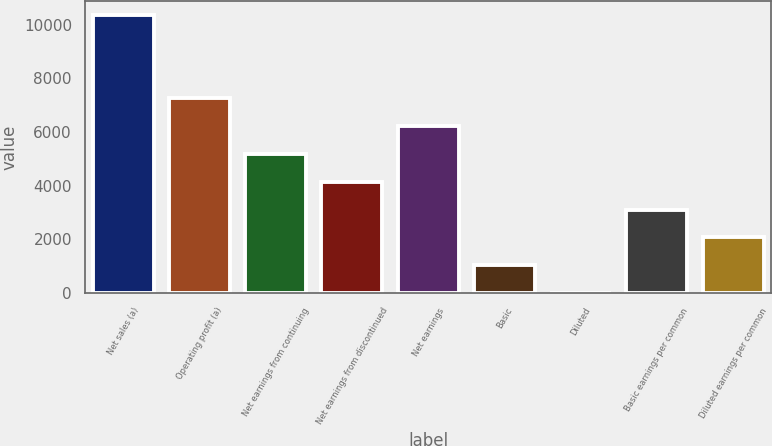Convert chart to OTSL. <chart><loc_0><loc_0><loc_500><loc_500><bar_chart><fcel>Net sales (a)<fcel>Operating profit (a)<fcel>Net earnings from continuing<fcel>Net earnings from discontinued<fcel>Net earnings<fcel>Basic<fcel>Diluted<fcel>Basic earnings per common<fcel>Diluted earnings per common<nl><fcel>10368<fcel>7258.39<fcel>5185.31<fcel>4148.77<fcel>6221.85<fcel>1039.15<fcel>2.61<fcel>3112.23<fcel>2075.69<nl></chart> 